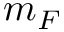<formula> <loc_0><loc_0><loc_500><loc_500>m _ { F }</formula> 